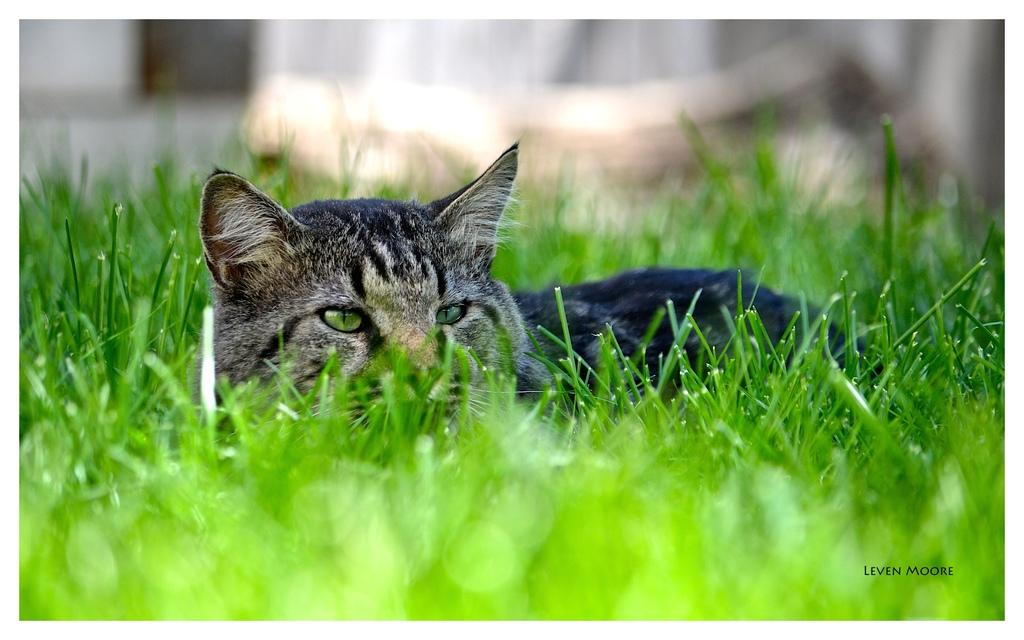What type of animal is in the image? There is a cat in the image. What is the cat doing in the image? The cat is laying on the grass. Can you describe the quality of the image? There is a blurred view at the top and bottom of the image. Is there any text or logo visible in the image? Yes, there is a watermark in the bottom right corner of the image. How does the cat say good-bye to the viewer in the image? The cat does not say good-bye in the image; it is simply laying on the grass. Is the cat a spy in the image? There is no indication in the image that the cat is a spy. 